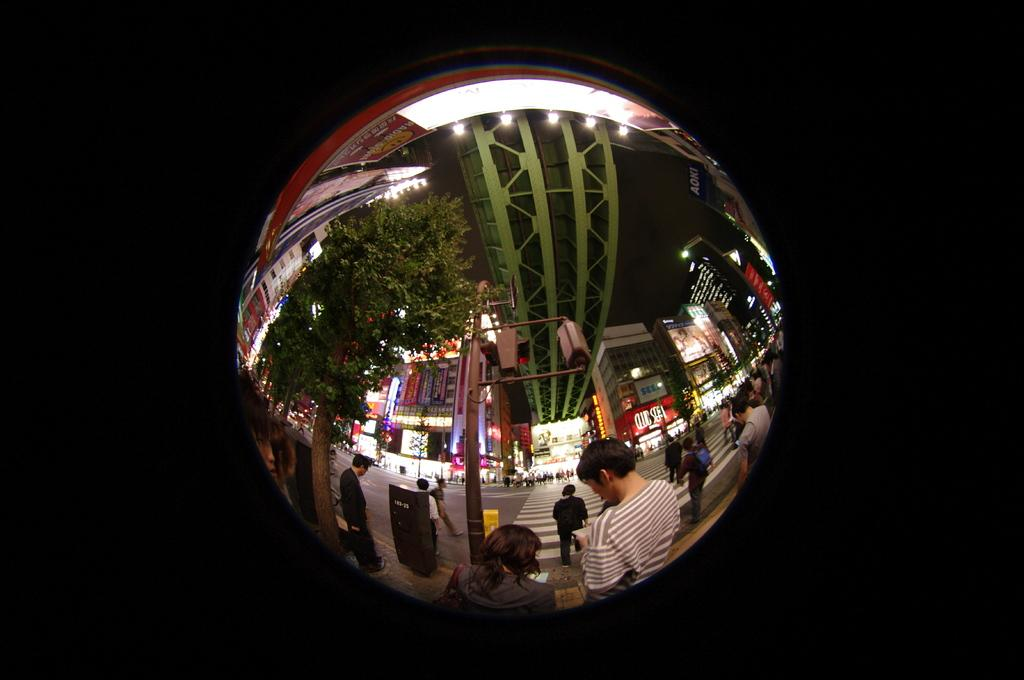What is the main subject of the image? The main subject of the image is a reflection of a group of people. What elements are included in the reflection? The reflection includes a road, buildings, trees, poles, lights, and iron pillars. What is the color of the background in the image? The background of the image is dark. How many centimeters does the clock in the image measure? There is no clock present in the image. What type of spoon is being used by the people in the image? There are no spoons visible in the image; it features a reflection of a group of people and various elements in the environment. 